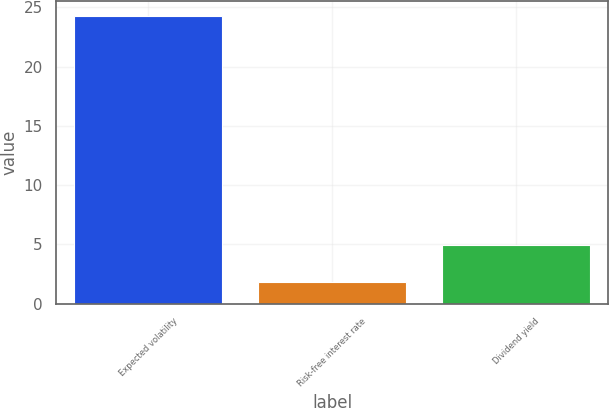Convert chart to OTSL. <chart><loc_0><loc_0><loc_500><loc_500><bar_chart><fcel>Expected volatility<fcel>Risk-free interest rate<fcel>Dividend yield<nl><fcel>24.3<fcel>1.8<fcel>4.9<nl></chart> 